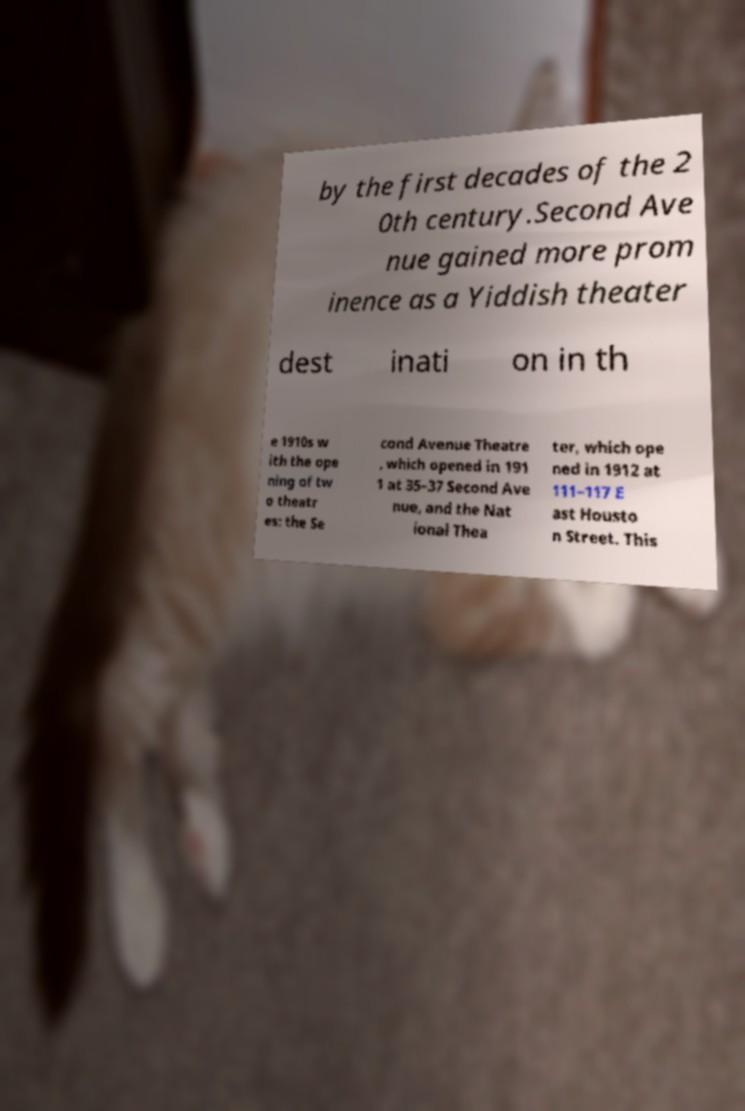There's text embedded in this image that I need extracted. Can you transcribe it verbatim? by the first decades of the 2 0th century.Second Ave nue gained more prom inence as a Yiddish theater dest inati on in th e 1910s w ith the ope ning of tw o theatr es: the Se cond Avenue Theatre , which opened in 191 1 at 35–37 Second Ave nue, and the Nat ional Thea ter, which ope ned in 1912 at 111–117 E ast Housto n Street. This 